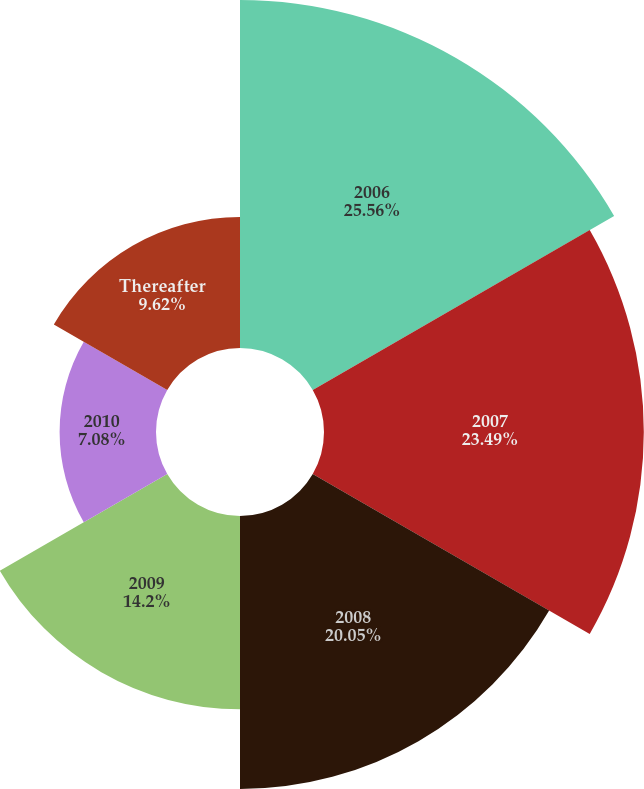Convert chart to OTSL. <chart><loc_0><loc_0><loc_500><loc_500><pie_chart><fcel>2006<fcel>2007<fcel>2008<fcel>2009<fcel>2010<fcel>Thereafter<nl><fcel>25.56%<fcel>23.49%<fcel>20.05%<fcel>14.2%<fcel>7.08%<fcel>9.62%<nl></chart> 